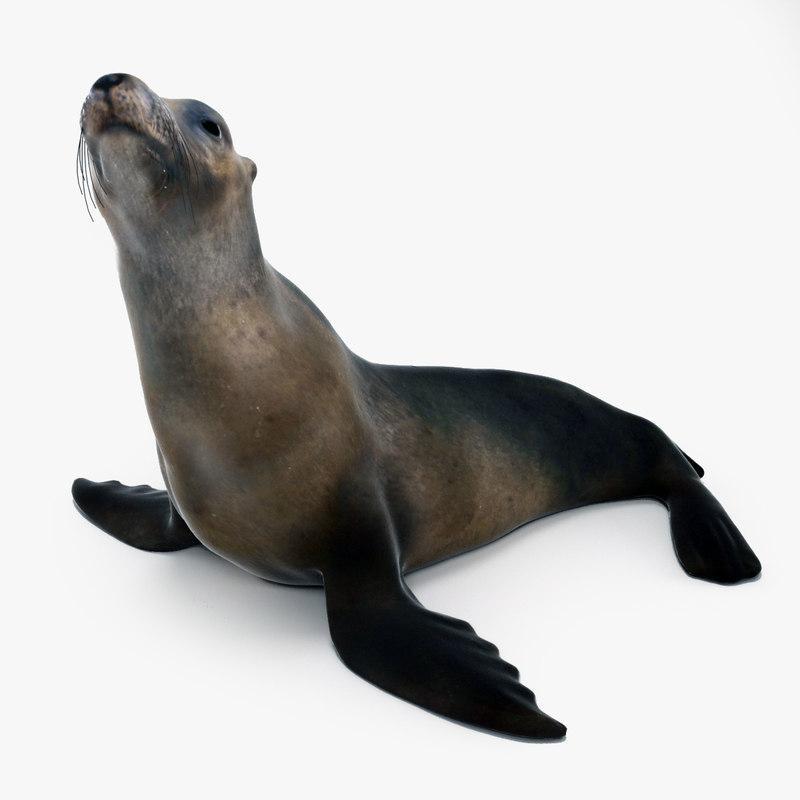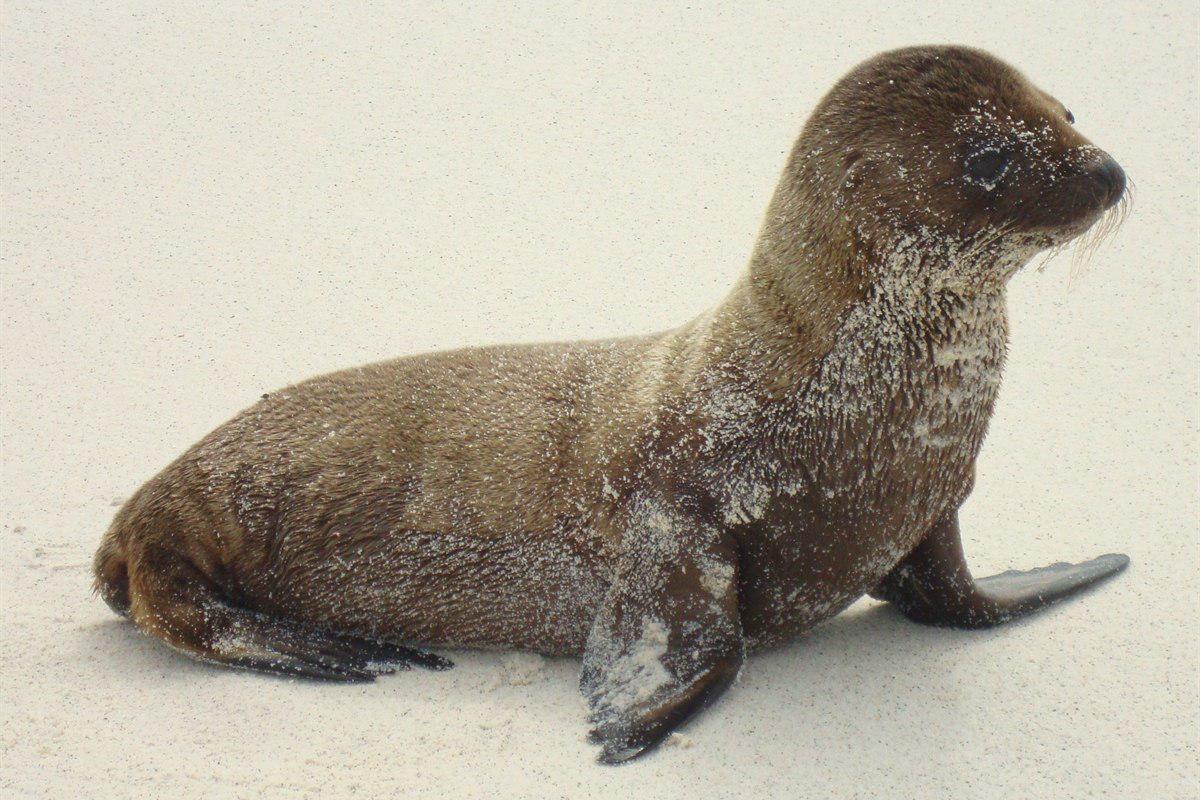The first image is the image on the left, the second image is the image on the right. Considering the images on both sides, is "1 seal is pointed toward the right outside." valid? Answer yes or no. Yes. 